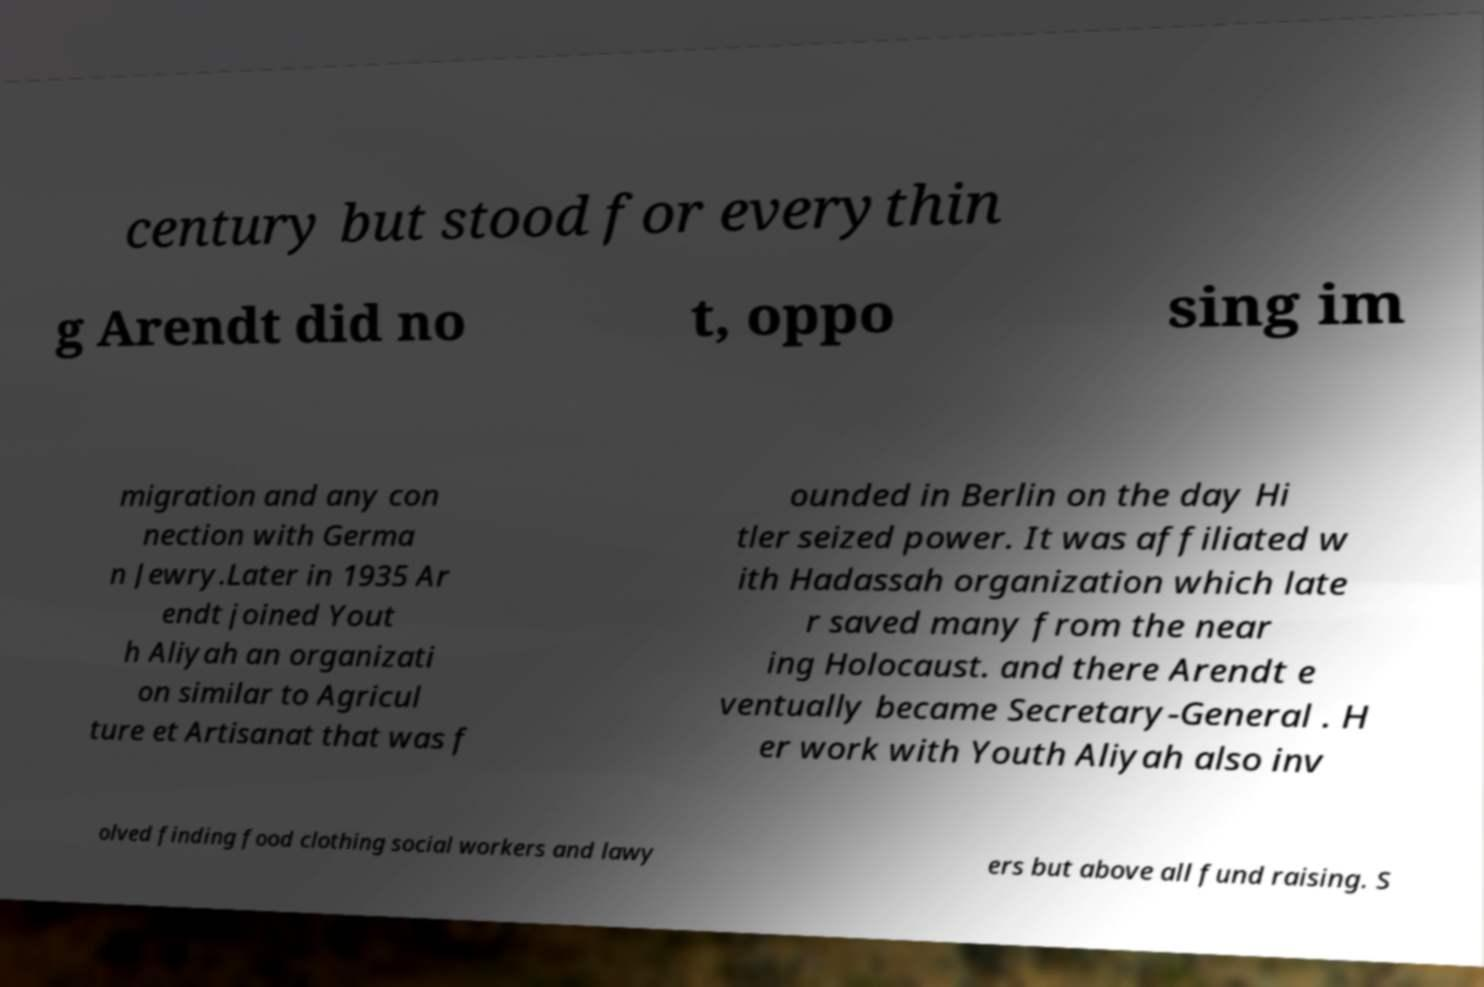For documentation purposes, I need the text within this image transcribed. Could you provide that? century but stood for everythin g Arendt did no t, oppo sing im migration and any con nection with Germa n Jewry.Later in 1935 Ar endt joined Yout h Aliyah an organizati on similar to Agricul ture et Artisanat that was f ounded in Berlin on the day Hi tler seized power. It was affiliated w ith Hadassah organization which late r saved many from the near ing Holocaust. and there Arendt e ventually became Secretary-General . H er work with Youth Aliyah also inv olved finding food clothing social workers and lawy ers but above all fund raising. S 